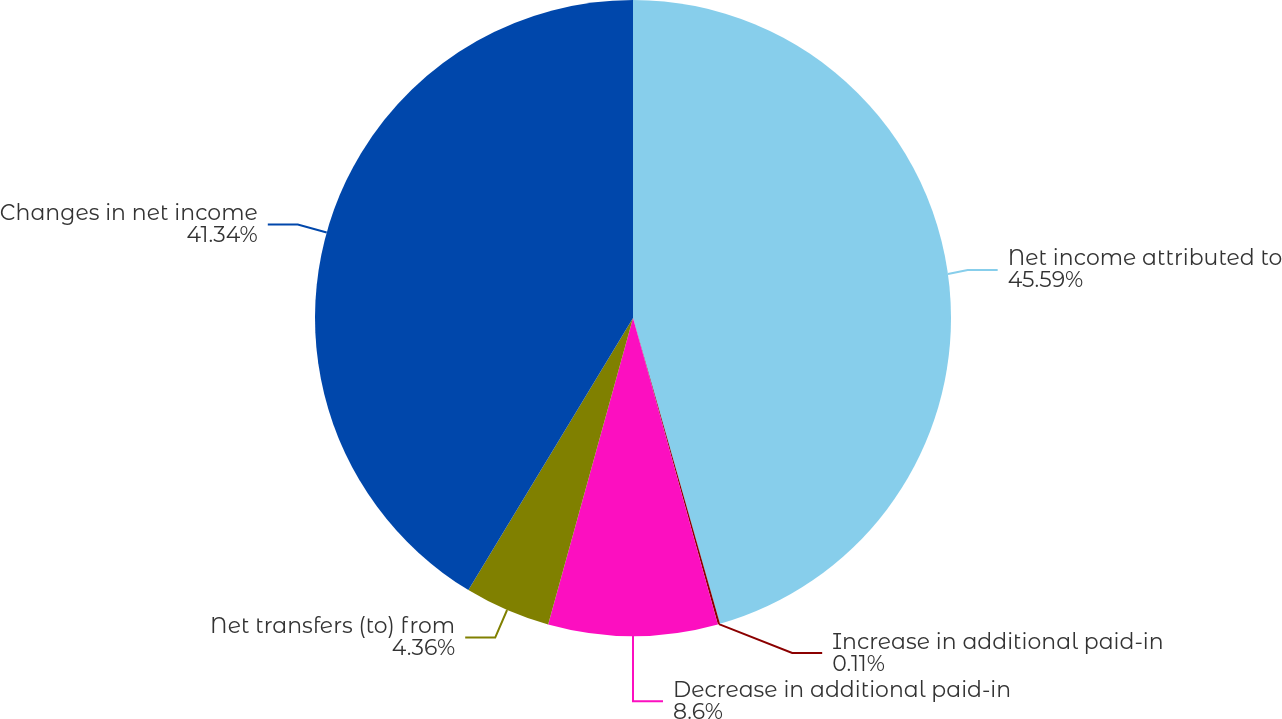<chart> <loc_0><loc_0><loc_500><loc_500><pie_chart><fcel>Net income attributed to<fcel>Increase in additional paid-in<fcel>Decrease in additional paid-in<fcel>Net transfers (to) from<fcel>Changes in net income<nl><fcel>45.59%<fcel>0.11%<fcel>8.6%<fcel>4.36%<fcel>41.34%<nl></chart> 